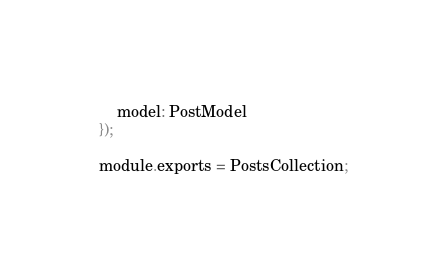<code> <loc_0><loc_0><loc_500><loc_500><_JavaScript_>	model: PostModel
});

module.exports = PostsCollection;</code> 